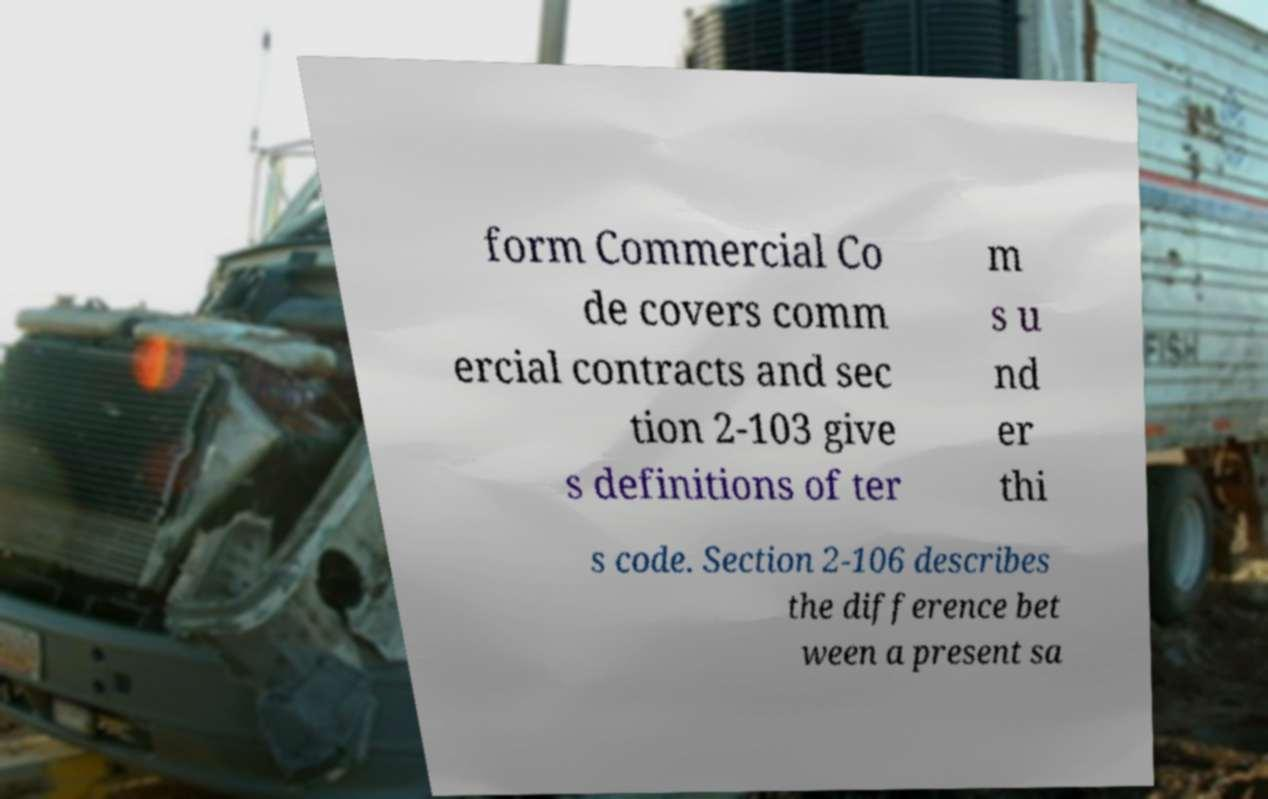What messages or text are displayed in this image? I need them in a readable, typed format. form Commercial Co de covers comm ercial contracts and sec tion 2-103 give s definitions of ter m s u nd er thi s code. Section 2-106 describes the difference bet ween a present sa 